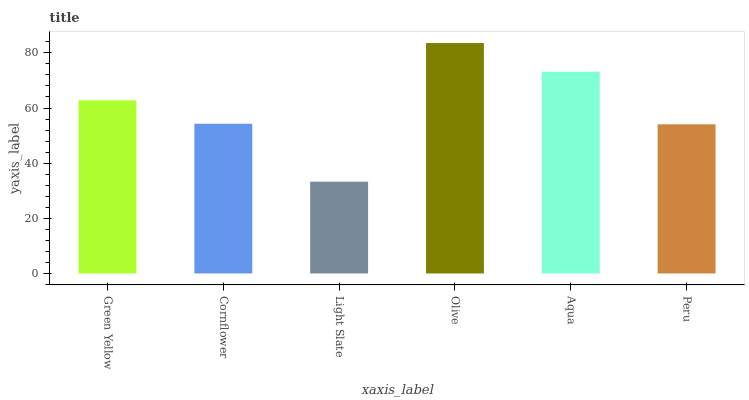Is Light Slate the minimum?
Answer yes or no. Yes. Is Olive the maximum?
Answer yes or no. Yes. Is Cornflower the minimum?
Answer yes or no. No. Is Cornflower the maximum?
Answer yes or no. No. Is Green Yellow greater than Cornflower?
Answer yes or no. Yes. Is Cornflower less than Green Yellow?
Answer yes or no. Yes. Is Cornflower greater than Green Yellow?
Answer yes or no. No. Is Green Yellow less than Cornflower?
Answer yes or no. No. Is Green Yellow the high median?
Answer yes or no. Yes. Is Cornflower the low median?
Answer yes or no. Yes. Is Light Slate the high median?
Answer yes or no. No. Is Light Slate the low median?
Answer yes or no. No. 